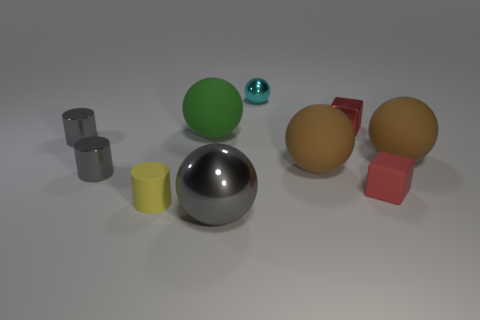Subtract all yellow cylinders. How many brown balls are left? 2 Subtract all gray cylinders. How many cylinders are left? 1 Subtract all gray balls. How many balls are left? 4 Subtract all cylinders. How many objects are left? 7 Subtract all blue balls. Subtract all green cylinders. How many balls are left? 5 Add 3 small yellow cylinders. How many small yellow cylinders are left? 4 Add 6 metallic cylinders. How many metallic cylinders exist? 8 Subtract 0 red balls. How many objects are left? 10 Subtract all purple metallic objects. Subtract all tiny gray shiny cylinders. How many objects are left? 8 